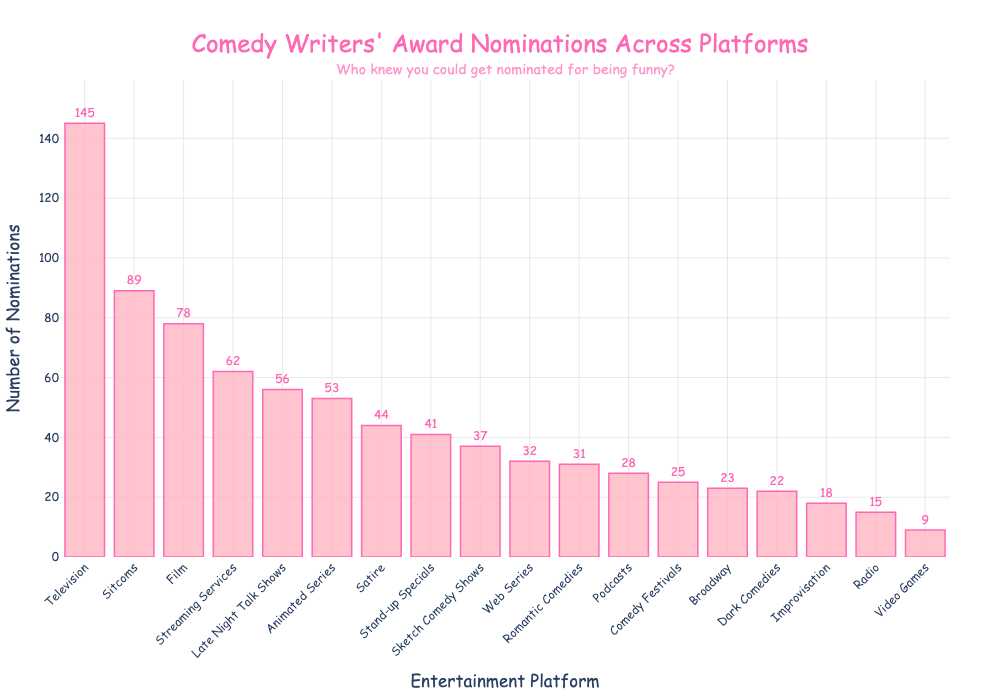Which platform has the highest number of award nominations? By looking at the heights of the bars in the bar chart, the Television platform has the tallest bar, indicating it has the highest number of nominations.
Answer: Television What is the difference in the number of nominations between Television and Film? The number of nominations for Television is 145, and for Film, it is 78. The difference is calculated as 145 - 78.
Answer: 67 Which has more nominations: Animated Series or Podcasts? Comparing the heights of the bars for Animated Series and Podcasts, Animated Series has a taller bar. Therefore, it has more nominations.
Answer: Animated Series Sum the number of nominations for Web Series, Podcasts, and Stand-up Specials. Adding the nominations for Web Series (32), Podcasts (28), and Stand-up Specials (41) gives 32 + 28 + 41.
Answer: 101 Is the number of nominations for Sitcoms greater than that for Late Night Talk Shows? Comparing the heights of the bars for Sitcoms and Late Night Talk Shows, the Sitcoms bar is taller. So, Sitcoms have more nominations.
Answer: Yes What's the median value of nominations across all platforms? List out all the nominations: 145, 78, 32, 62, 23, 15, 28, 9, 41, 53, 37, 56, 89, 31, 22, 44, 18, 25. Arrange them in an ascending order: 9, 15, 18, 22, 23, 25, 28, 31, 32, 37, 41, 44, 53, 56, 62, 78, 89, 145. The middle values are 31 and 32, so the median is (31+32)/2.
Answer: 31.5 What is the range of the nominations? The range is calculated by subtracting the smallest value (Radio with 15 nominations) from the largest value (Television with 145 nominations). So, 145 - 9.
Answer: 136 How many platforms have more than 50 nominations? Counting the number of bars that are taller than the bar representing 50 nominations, the platforms are Television, Sitcoms, Film, Streaming Services, Animated Series, and Late Night Talk Shows. There are 6 such platforms.
Answer: 6 Which platform has the lowest number of nominations? By looking at the shortest bar in the bar chart, Video Games have the lowest number of nominations.
Answer: Video Games 